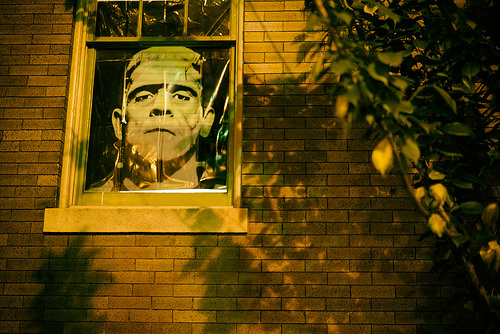<image>
Can you confirm if the picture is behind the window? Yes. From this viewpoint, the picture is positioned behind the window, with the window partially or fully occluding the picture. 